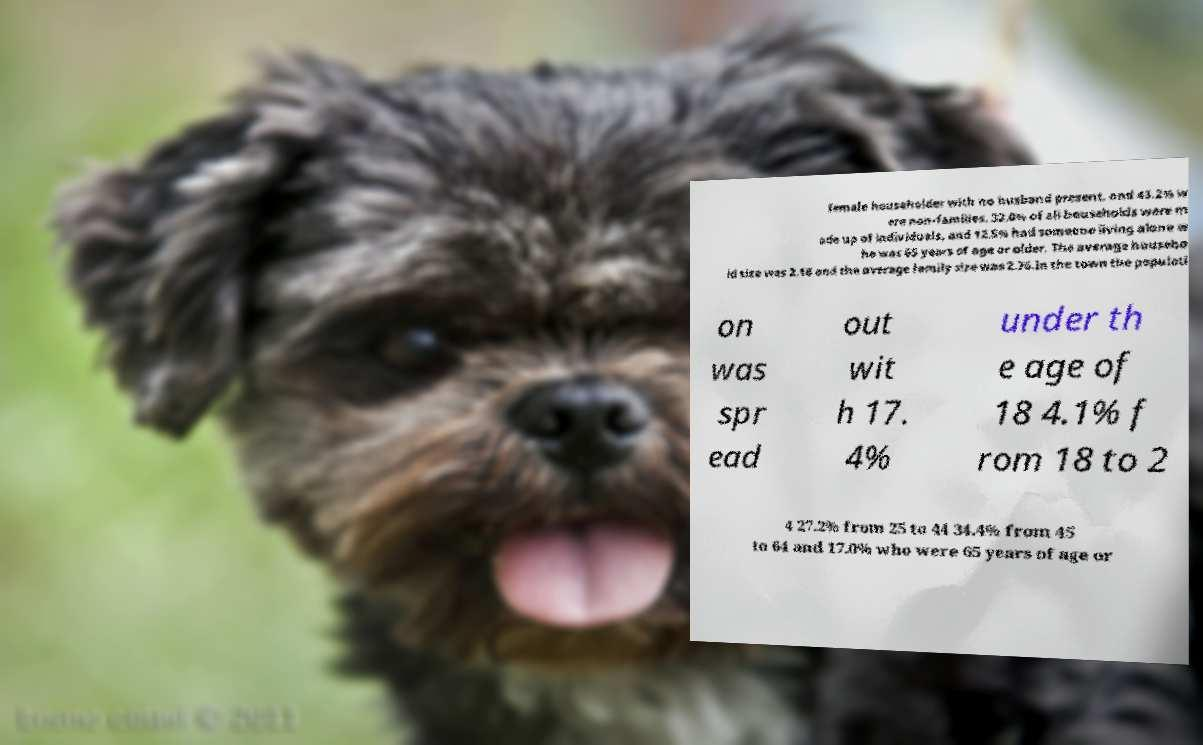Please read and relay the text visible in this image. What does it say? female householder with no husband present, and 43.2% w ere non-families. 32.0% of all households were m ade up of individuals, and 12.5% had someone living alone w ho was 65 years of age or older. The average househo ld size was 2.18 and the average family size was 2.76.In the town the populati on was spr ead out wit h 17. 4% under th e age of 18 4.1% f rom 18 to 2 4 27.2% from 25 to 44 34.4% from 45 to 64 and 17.0% who were 65 years of age or 